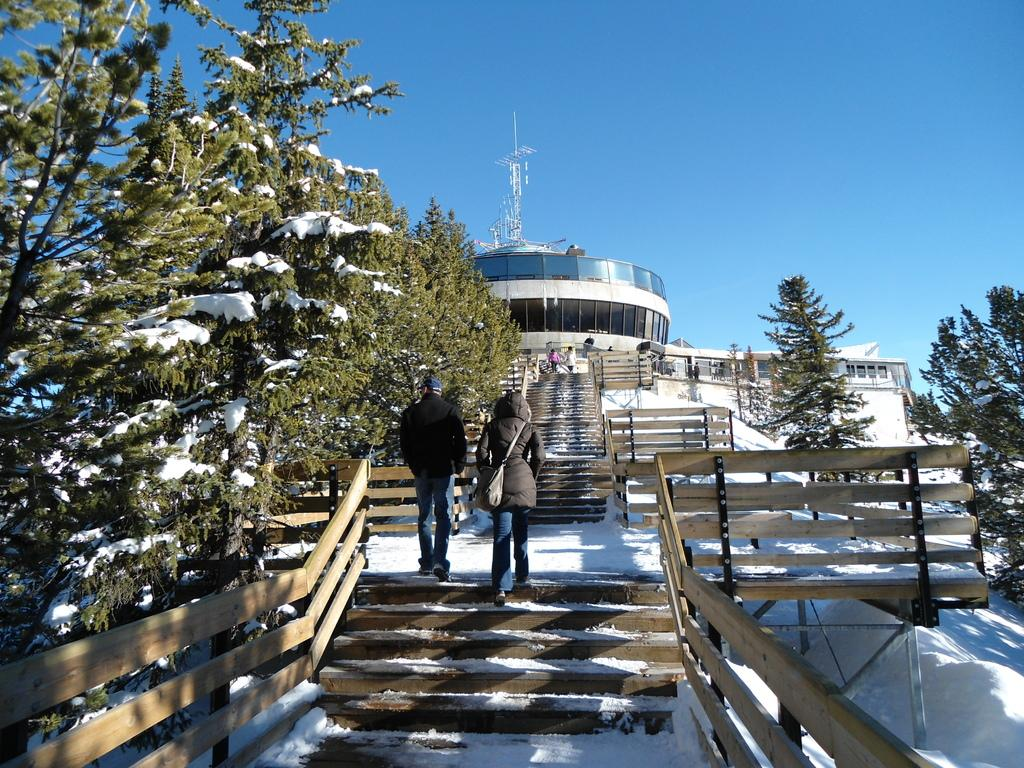What are the people in the image doing? The people in the image are climbing stairs. What is the weather like in the image? There is snow in the image, indicating a cold and wintry environment. What can be seen in the background of the image? There is a building, trees, and the sky visible in the background of the image. What type of apparatus is being used by the pets in the image? There are no pets present in the image, and therefore no apparatus can be associated with them. What kind of pancake is being served to the people climbing stairs in the image? There is no pancake present in the image; the people are climbing stairs in a snowy environment. 